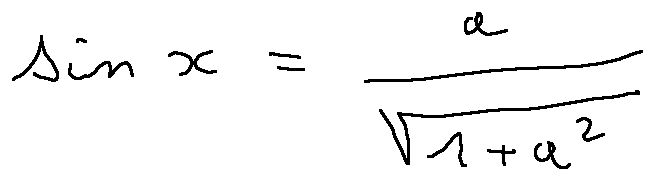Convert formula to latex. <formula><loc_0><loc_0><loc_500><loc_500>\sin x = \frac { a } { \sqrt { 1 + a ^ { 2 } } }</formula> 